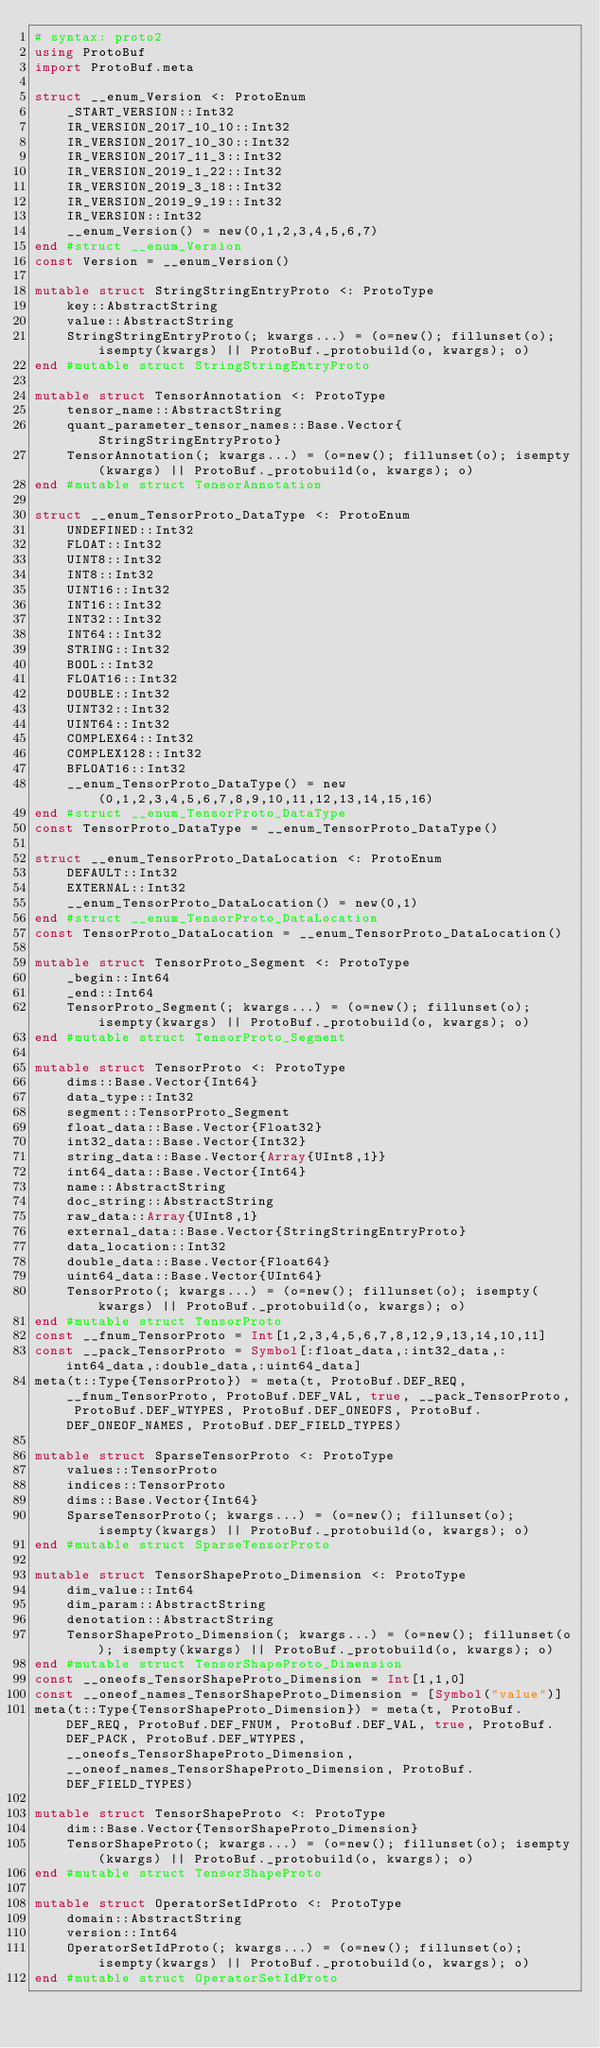Convert code to text. <code><loc_0><loc_0><loc_500><loc_500><_Julia_># syntax: proto2
using ProtoBuf
import ProtoBuf.meta

struct __enum_Version <: ProtoEnum
    _START_VERSION::Int32
    IR_VERSION_2017_10_10::Int32
    IR_VERSION_2017_10_30::Int32
    IR_VERSION_2017_11_3::Int32
    IR_VERSION_2019_1_22::Int32
    IR_VERSION_2019_3_18::Int32
    IR_VERSION_2019_9_19::Int32
    IR_VERSION::Int32
    __enum_Version() = new(0,1,2,3,4,5,6,7)
end #struct __enum_Version
const Version = __enum_Version()

mutable struct StringStringEntryProto <: ProtoType
    key::AbstractString
    value::AbstractString
    StringStringEntryProto(; kwargs...) = (o=new(); fillunset(o); isempty(kwargs) || ProtoBuf._protobuild(o, kwargs); o)
end #mutable struct StringStringEntryProto

mutable struct TensorAnnotation <: ProtoType
    tensor_name::AbstractString
    quant_parameter_tensor_names::Base.Vector{StringStringEntryProto}
    TensorAnnotation(; kwargs...) = (o=new(); fillunset(o); isempty(kwargs) || ProtoBuf._protobuild(o, kwargs); o)
end #mutable struct TensorAnnotation

struct __enum_TensorProto_DataType <: ProtoEnum
    UNDEFINED::Int32
    FLOAT::Int32
    UINT8::Int32
    INT8::Int32
    UINT16::Int32
    INT16::Int32
    INT32::Int32
    INT64::Int32
    STRING::Int32
    BOOL::Int32
    FLOAT16::Int32
    DOUBLE::Int32
    UINT32::Int32
    UINT64::Int32
    COMPLEX64::Int32
    COMPLEX128::Int32
    BFLOAT16::Int32
    __enum_TensorProto_DataType() = new(0,1,2,3,4,5,6,7,8,9,10,11,12,13,14,15,16)
end #struct __enum_TensorProto_DataType
const TensorProto_DataType = __enum_TensorProto_DataType()

struct __enum_TensorProto_DataLocation <: ProtoEnum
    DEFAULT::Int32
    EXTERNAL::Int32
    __enum_TensorProto_DataLocation() = new(0,1)
end #struct __enum_TensorProto_DataLocation
const TensorProto_DataLocation = __enum_TensorProto_DataLocation()

mutable struct TensorProto_Segment <: ProtoType
    _begin::Int64
    _end::Int64
    TensorProto_Segment(; kwargs...) = (o=new(); fillunset(o); isempty(kwargs) || ProtoBuf._protobuild(o, kwargs); o)
end #mutable struct TensorProto_Segment

mutable struct TensorProto <: ProtoType
    dims::Base.Vector{Int64}
    data_type::Int32
    segment::TensorProto_Segment
    float_data::Base.Vector{Float32}
    int32_data::Base.Vector{Int32}
    string_data::Base.Vector{Array{UInt8,1}}
    int64_data::Base.Vector{Int64}
    name::AbstractString
    doc_string::AbstractString
    raw_data::Array{UInt8,1}
    external_data::Base.Vector{StringStringEntryProto}
    data_location::Int32
    double_data::Base.Vector{Float64}
    uint64_data::Base.Vector{UInt64}
    TensorProto(; kwargs...) = (o=new(); fillunset(o); isempty(kwargs) || ProtoBuf._protobuild(o, kwargs); o)
end #mutable struct TensorProto
const __fnum_TensorProto = Int[1,2,3,4,5,6,7,8,12,9,13,14,10,11]
const __pack_TensorProto = Symbol[:float_data,:int32_data,:int64_data,:double_data,:uint64_data]
meta(t::Type{TensorProto}) = meta(t, ProtoBuf.DEF_REQ, __fnum_TensorProto, ProtoBuf.DEF_VAL, true, __pack_TensorProto, ProtoBuf.DEF_WTYPES, ProtoBuf.DEF_ONEOFS, ProtoBuf.DEF_ONEOF_NAMES, ProtoBuf.DEF_FIELD_TYPES)

mutable struct SparseTensorProto <: ProtoType
    values::TensorProto
    indices::TensorProto
    dims::Base.Vector{Int64}
    SparseTensorProto(; kwargs...) = (o=new(); fillunset(o); isempty(kwargs) || ProtoBuf._protobuild(o, kwargs); o)
end #mutable struct SparseTensorProto

mutable struct TensorShapeProto_Dimension <: ProtoType
    dim_value::Int64
    dim_param::AbstractString
    denotation::AbstractString
    TensorShapeProto_Dimension(; kwargs...) = (o=new(); fillunset(o); isempty(kwargs) || ProtoBuf._protobuild(o, kwargs); o)
end #mutable struct TensorShapeProto_Dimension
const __oneofs_TensorShapeProto_Dimension = Int[1,1,0]
const __oneof_names_TensorShapeProto_Dimension = [Symbol("value")]
meta(t::Type{TensorShapeProto_Dimension}) = meta(t, ProtoBuf.DEF_REQ, ProtoBuf.DEF_FNUM, ProtoBuf.DEF_VAL, true, ProtoBuf.DEF_PACK, ProtoBuf.DEF_WTYPES, __oneofs_TensorShapeProto_Dimension, __oneof_names_TensorShapeProto_Dimension, ProtoBuf.DEF_FIELD_TYPES)

mutable struct TensorShapeProto <: ProtoType
    dim::Base.Vector{TensorShapeProto_Dimension}
    TensorShapeProto(; kwargs...) = (o=new(); fillunset(o); isempty(kwargs) || ProtoBuf._protobuild(o, kwargs); o)
end #mutable struct TensorShapeProto

mutable struct OperatorSetIdProto <: ProtoType
    domain::AbstractString
    version::Int64
    OperatorSetIdProto(; kwargs...) = (o=new(); fillunset(o); isempty(kwargs) || ProtoBuf._protobuild(o, kwargs); o)
end #mutable struct OperatorSetIdProto
</code> 